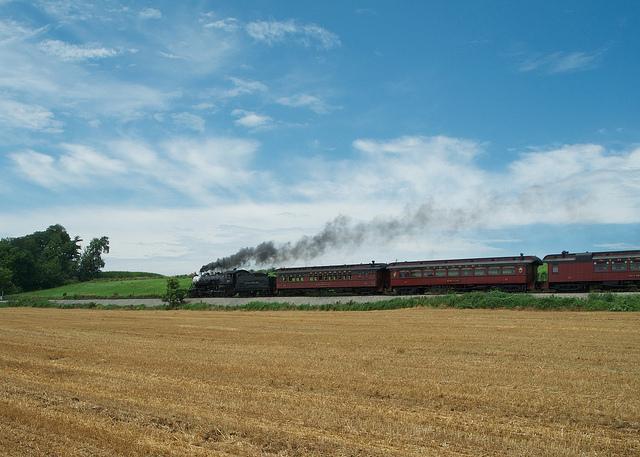How many cars are attached to the train?
Give a very brief answer. 3. How many compartments?
Give a very brief answer. 3. 